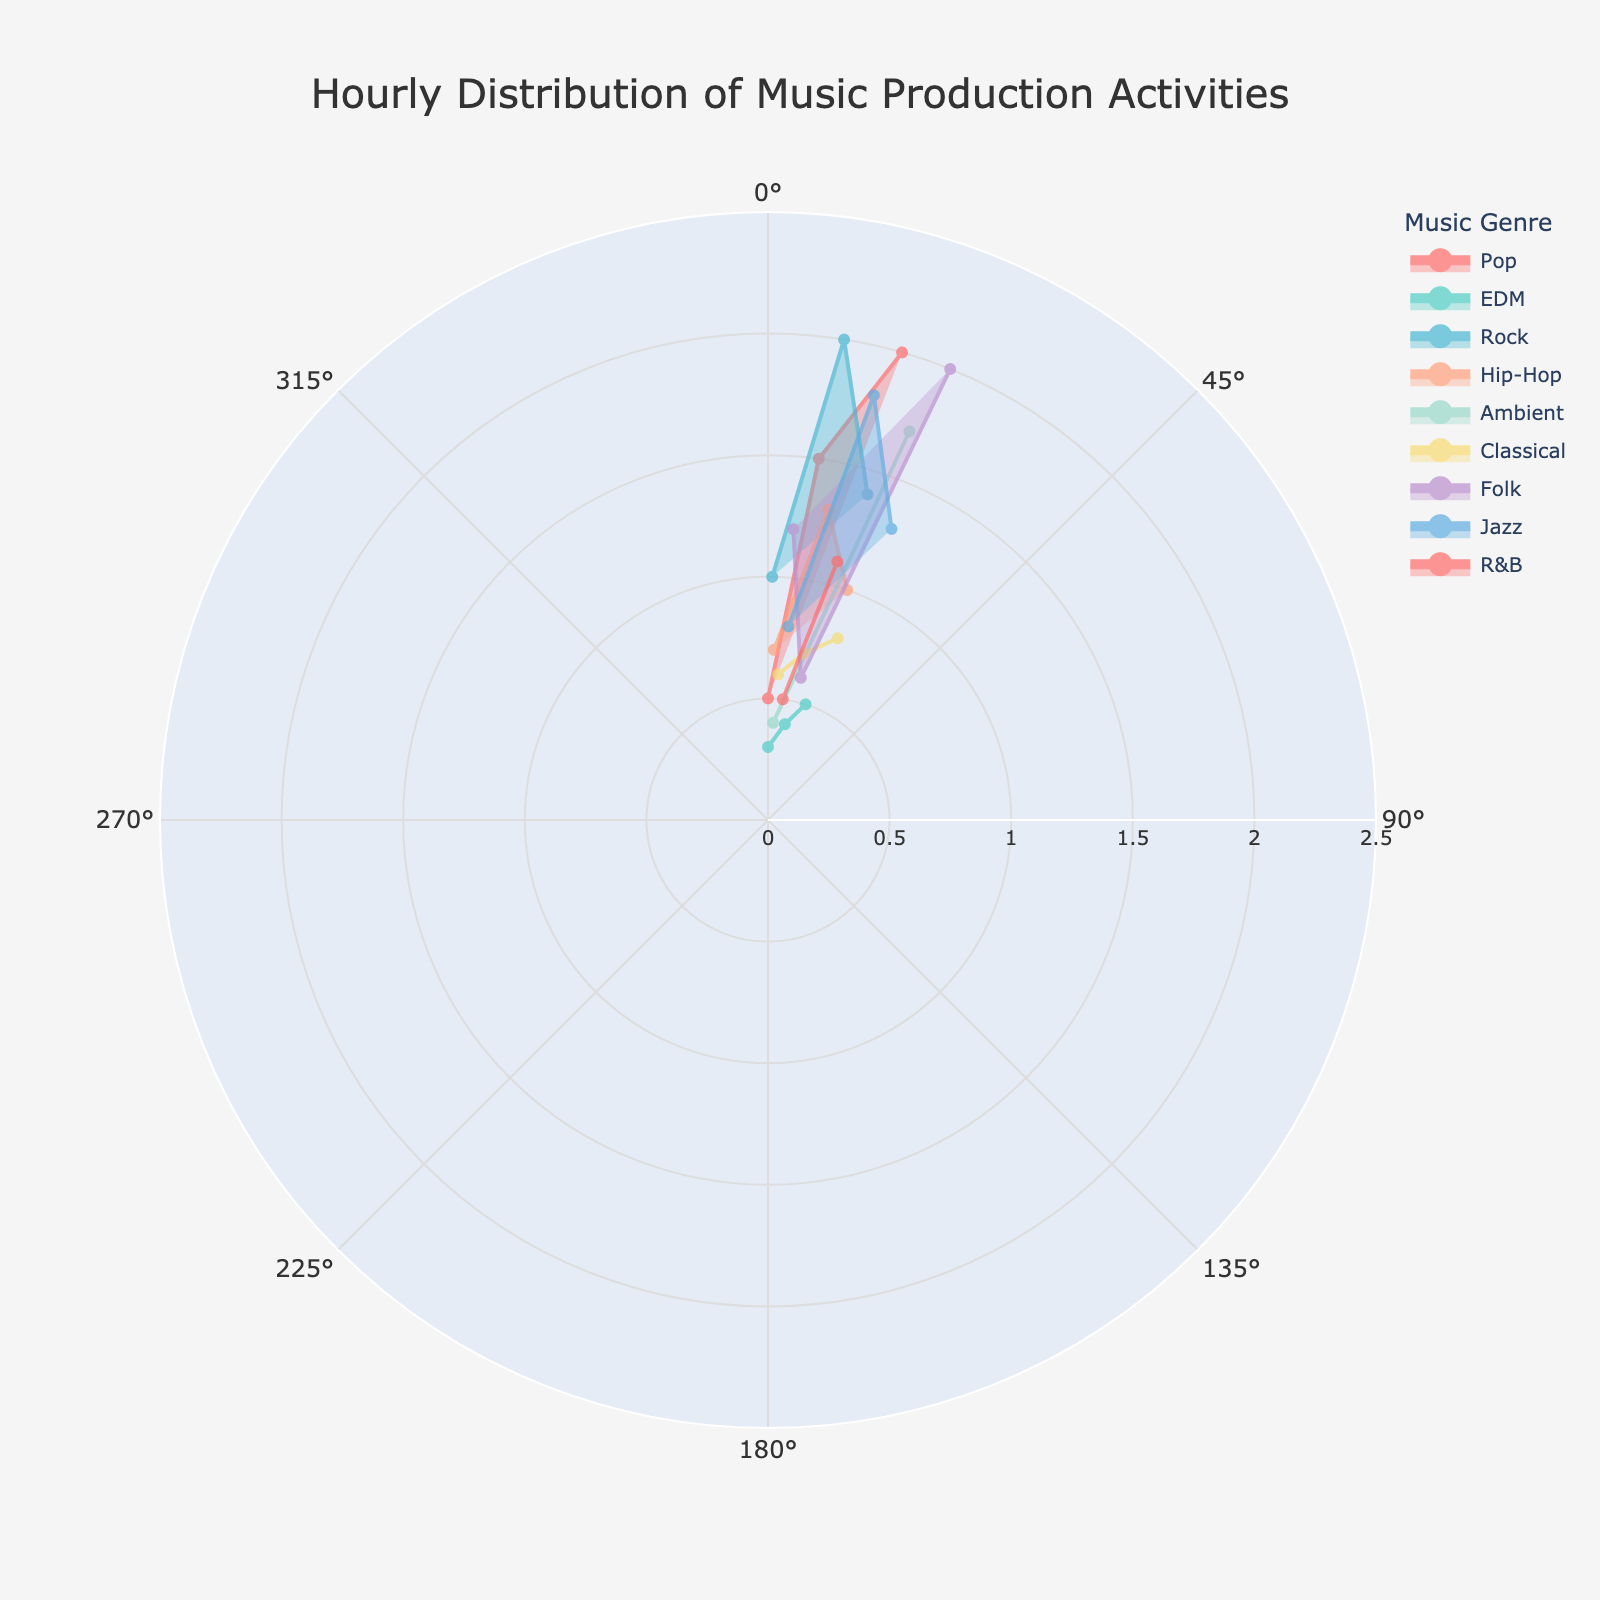What is the title of the figure? The title of the figure is displayed at the top and it reads "Hourly Distribution of Music Production Activities".
Answer: Hourly Distribution of Music Production Activities How many unique genres are plotted in the figure? By counting the different legends associated with each genre in the figure, we can see there are 8 unique genres.
Answer: 8 Which hour shows the highest duration for any activity? By inspecting the radial length of the spokes for each hour, the highest duration of 2.0 is at both the 9-10 and 16-17 hours.
Answer: 9-10 and 16-17 What is the total duration for Classical music activities? The durations for Classical activities are 0.6, 0.7, and 0.8. Summing these values gives 0.6 + 0.7 + 0.8 = 2.1 hours.
Answer: 2.1 hours Which genre has the most varied activity durations throughout the day? Examining the figure, Rock shows the widest spread in durations with values like 1.0, 2.0, and 1.4 hours, indicating variability.
Answer: Rock How does the duration of Pop activities from 0-1 compare to 8-9? The duration of Pop activities from 0-1 is 0.5, while for 8-9 it is 1.5. The latter is greater.
Answer: 8-9 has a greater duration What is the shortest activity duration recorded and which genre and hour does it correspond to? The shortest duration is 0.3 hours recorded for EDM during the 0-1 hour slot as seen by the shortest radial distance in the figure.
Answer: 0-1, EDM Calculate the average duration for Jazz activities. The durations for Jazz activities are 0.8, 1.8, and 1.3. The sum of these is 0.8 + 1.8 + 1.3 = 3.9 hours. There are 3 activities, so the average duration is 3.9/3 ≈ 1.3 hours.
Answer: 1.3 hours Which genre has the highest activity duration during the late evening (21-0)? By observing the activities from 21-0, Jazz has a duration of 1.3 during 23-0, which is the highest.
Answer: Jazz 